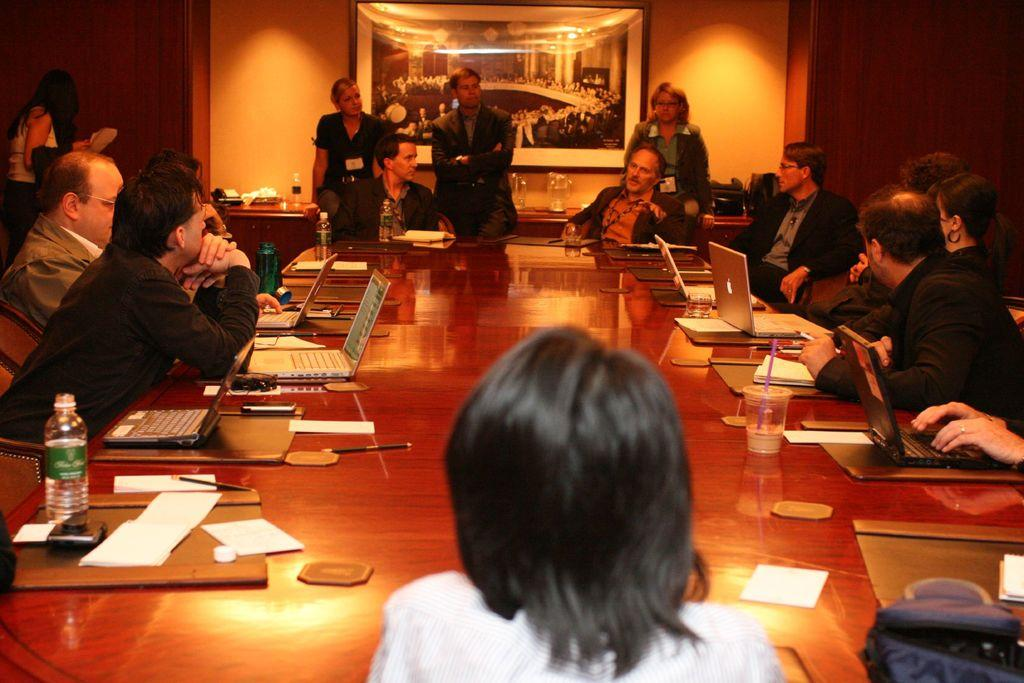What type of location is depicted in the image? The image depicts a conference hall. What are the people in the conference hall doing? The people are sitting on chairs in the conference hall. How are the chairs arranged in the conference hall? The chairs are arranged around a table. What electronic devices can be seen on the table? There are laptops on the table. What else is present on the table besides laptops? There are bottles and papers on the table. What type of tools does the carpenter use in the image? There is no carpenter present in the image; it depicts a conference hall with people sitting around a table. What type of nut is being cracked open by the people in the image? There are no nuts present in the image, and the people are not engaged in any activity related to cracking nuts. 